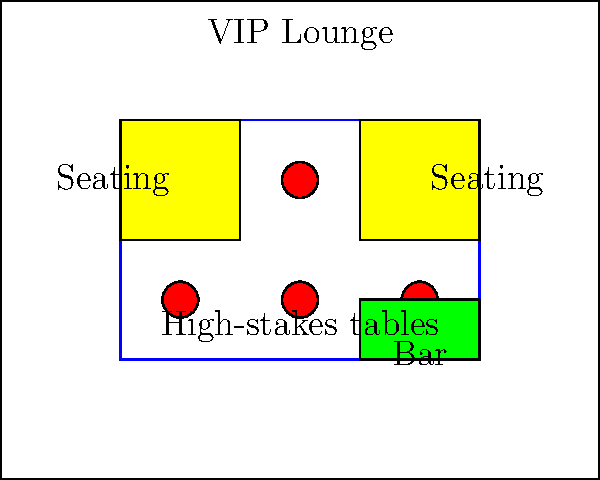Based on the VIP lounge layout shown, which design element is strategically placed to encourage longer player sessions and potentially higher bets? To answer this question, we need to analyze the layout of the VIP lounge with a focus on elements that could encourage longer player sessions and higher bets. Let's break down the key components:

1. High-stakes game tables (red circles): These are centrally located, providing easy access for players.

2. Bar area (green rectangle): This is positioned at the right side of the lounge.

3. Comfortable seating areas (yellow rectangles): These are placed on both sides of the high-stakes tables.

4. Overall layout: The design creates a flow that keeps players close to the gaming tables.

The strategic element in this layout is the bar area. Here's why:

1. Proximity to games: The bar is close to the high-stakes tables, allowing players to quickly get drinks without leaving the gaming area.

2. Encourages socializing: The bar provides a space for players to relax and socialize, which can lead to longer stays in the lounge.

3. Reduced interruptions: With the bar inside the VIP lounge, players don't need to leave to get drinks, maintaining the exclusive atmosphere and reducing breaks in play.

4. Potential for higher spending: Easy access to drinks can lower inhibitions, potentially leading to higher bets.

5. Creates a complete experience: The combination of gaming, drinks, and comfortable seating allows players to spend extended periods in the lounge without feeling the need to leave.

The placement of the bar, therefore, is a key strategic element in encouraging longer player sessions and potentially higher bets.
Answer: The strategically placed bar 